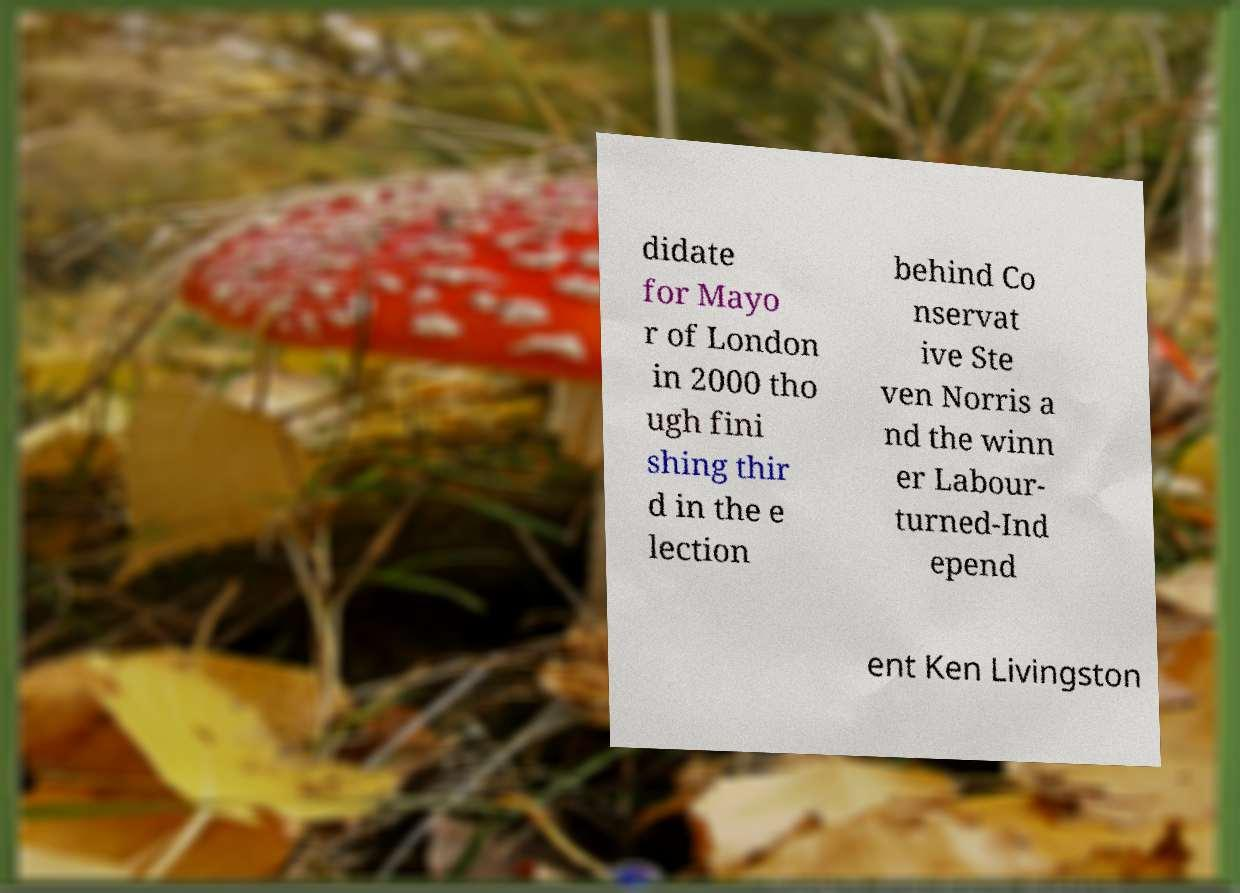Can you accurately transcribe the text from the provided image for me? didate for Mayo r of London in 2000 tho ugh fini shing thir d in the e lection behind Co nservat ive Ste ven Norris a nd the winn er Labour- turned-Ind epend ent Ken Livingston 